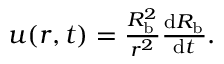<formula> <loc_0><loc_0><loc_500><loc_500>\begin{array} { r } { u ( r , t ) = \frac { R _ { b } ^ { 2 } } { r ^ { 2 } } \frac { \mathrm d R _ { b } } { \mathrm d t } . } \end{array}</formula> 